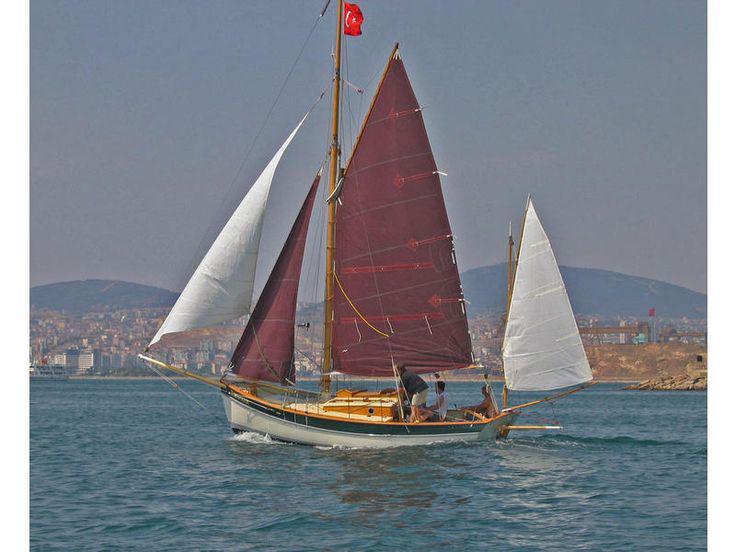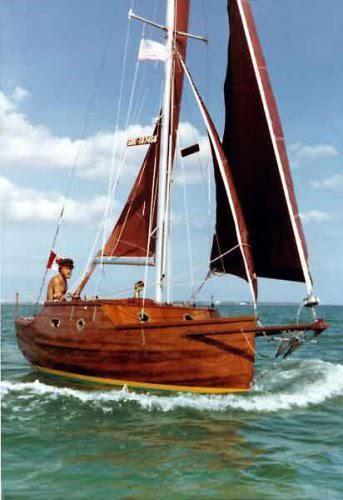The first image is the image on the left, the second image is the image on the right. Assess this claim about the two images: "The sails on both boats are nearly the same color.". Correct or not? Answer yes or no. No. 